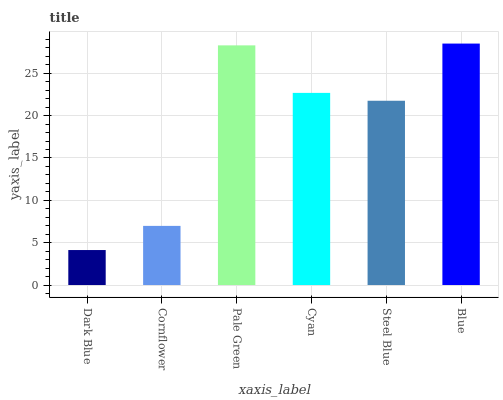Is Dark Blue the minimum?
Answer yes or no. Yes. Is Blue the maximum?
Answer yes or no. Yes. Is Cornflower the minimum?
Answer yes or no. No. Is Cornflower the maximum?
Answer yes or no. No. Is Cornflower greater than Dark Blue?
Answer yes or no. Yes. Is Dark Blue less than Cornflower?
Answer yes or no. Yes. Is Dark Blue greater than Cornflower?
Answer yes or no. No. Is Cornflower less than Dark Blue?
Answer yes or no. No. Is Cyan the high median?
Answer yes or no. Yes. Is Steel Blue the low median?
Answer yes or no. Yes. Is Pale Green the high median?
Answer yes or no. No. Is Cornflower the low median?
Answer yes or no. No. 